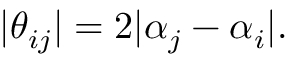Convert formula to latex. <formula><loc_0><loc_0><loc_500><loc_500>| \theta _ { i j } | = 2 | \alpha _ { j } - \alpha _ { i } | .</formula> 